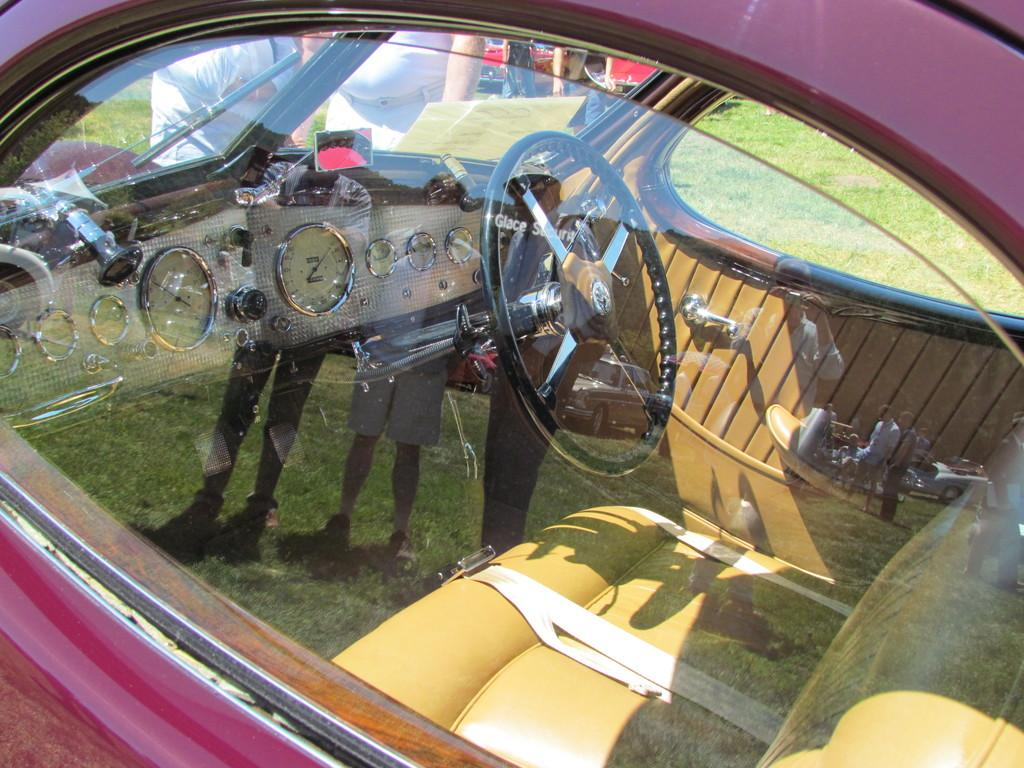What is the main subject of the image? The main subject of the image is a car. What feature is present inside the car? The car has a steering wheel. What part of the car is transparent? The car has a window. What is the color of the car in the image? The car is maroon in color. Can you tell me how many servants are standing next to the car in the image? There are no servants present in the image; it only features a car. What type of rifle is visible in the image? There is no rifle present in the image; it only features a car. 